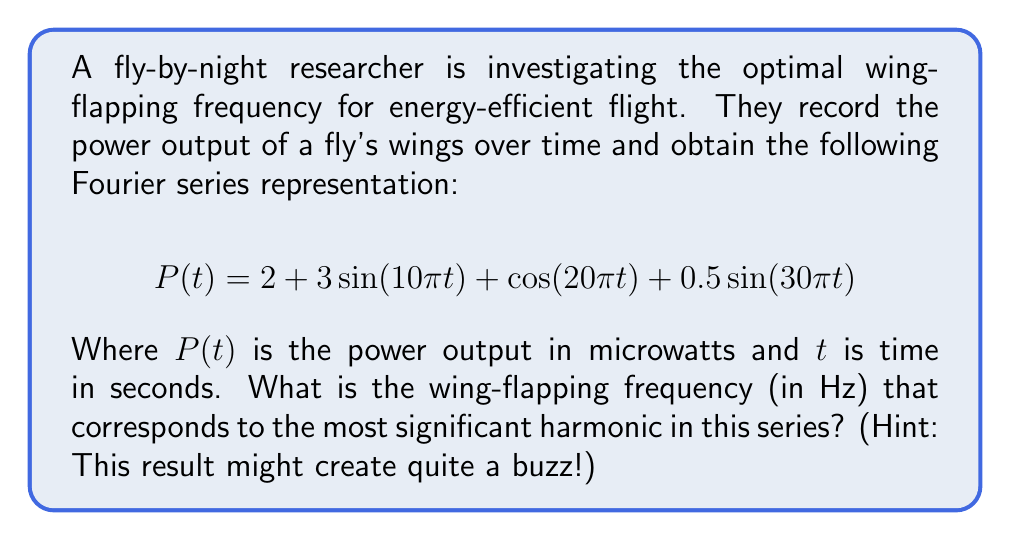Can you answer this question? To determine the optimal wing-flapping frequency, we need to identify the most significant harmonic in the Fourier series. Let's break it down step-by-step:

1) The given Fourier series is:
   $$ P(t) = 2 + 3\sin(10\pi t) + \cos(20\pi t) + 0.5\sin(30\pi t) $$

2) Each term represents a different frequency component:
   - $2$ is the constant term (0 Hz)
   - $3\sin(10\pi t)$ has a frequency of $5$ Hz
   - $\cos(20\pi t)$ has a frequency of $10$ Hz
   - $0.5\sin(30\pi t)$ has a frequency of $15$ Hz

3) To find the frequency, we use the relationship:
   $$ f = \frac{\omega}{2\pi} $$
   where $f$ is frequency in Hz and $\omega$ is angular frequency in rad/s.

4) The amplitudes of each term are:
   - Constant term: 2
   - $5$ Hz term: 3
   - $10$ Hz term: 1
   - $15$ Hz term: 0.5

5) The most significant harmonic is the one with the largest amplitude, which is 3, corresponding to the $5$ Hz term.

Therefore, the wing-flapping frequency that corresponds to the most significant harmonic is 5 Hz.
Answer: 5 Hz 